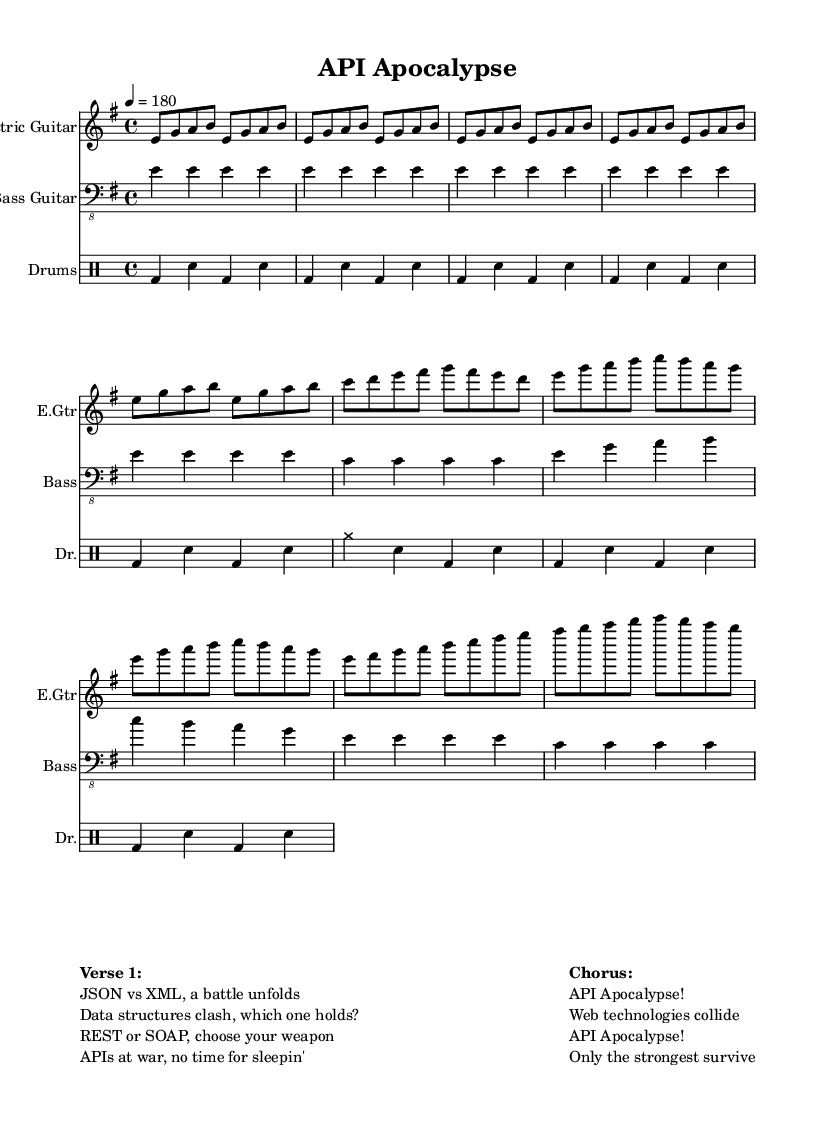What is the key signature of this music? The key signature is E minor, which has one sharp (F#). This can be determined from the key signature that is indicated at the beginning of the piece.
Answer: E minor What is the time signature of this music? The time signature is 4/4, indicating four beats per measure and a quarter note receives one beat. This is explicitly stated at the beginning of the score.
Answer: 4/4 What is the tempo marking of this music? The tempo marking is set to 180 beats per minute, as indicated by the tempo notation in the score. This means the music should be played quickly.
Answer: 180 How many measures are in the chorus? The chorus consists of two measures, which can be counted by examining the lines in the chorus section of the sheet music, where the notes are grouped together.
Answer: 2 What instruments are included in the arrangement? The arrangement includes Electric Guitar, Bass Guitar, and Drums, as specified by the instrument names at the beginning of each staff in the score.
Answer: Electric Guitar, Bass Guitar, Drums What musical elements are used in the verse? The verse utilizes a simple melodic structure with ascending and descending notes primarily around the E minor scale, reflecting the typical rock style. By analyzing the notes in the verse section, we can see this pattern.
Answer: E minor scale patterns How does the theme of the lyrics relate to the music's intensity? The lyrics depict a battle between web technologies, with phrases suggesting conflict and urgency. This intense thematic element is matched by the fast tempo and driving rhythms in the music, creating a sense of excitement and drama. By studying both the lyrical content and the characteristics of the music, the relationship becomes evident.
Answer: Intensity aligns with battle imagery 